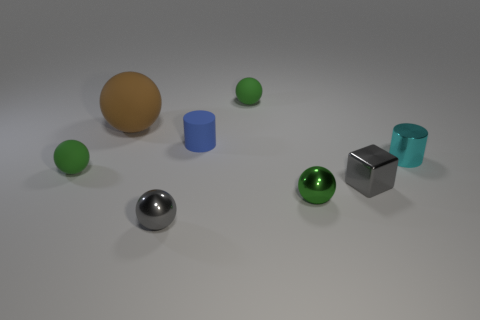Subtract all brown cubes. How many green balls are left? 3 Subtract all gray balls. How many balls are left? 4 Subtract all large spheres. How many spheres are left? 4 Subtract all brown balls. Subtract all brown cubes. How many balls are left? 4 Add 2 tiny gray spheres. How many objects exist? 10 Subtract all balls. How many objects are left? 3 Subtract 0 yellow cylinders. How many objects are left? 8 Subtract all small red metallic cylinders. Subtract all blue rubber objects. How many objects are left? 7 Add 3 tiny matte balls. How many tiny matte balls are left? 5 Add 5 big brown rubber things. How many big brown rubber things exist? 6 